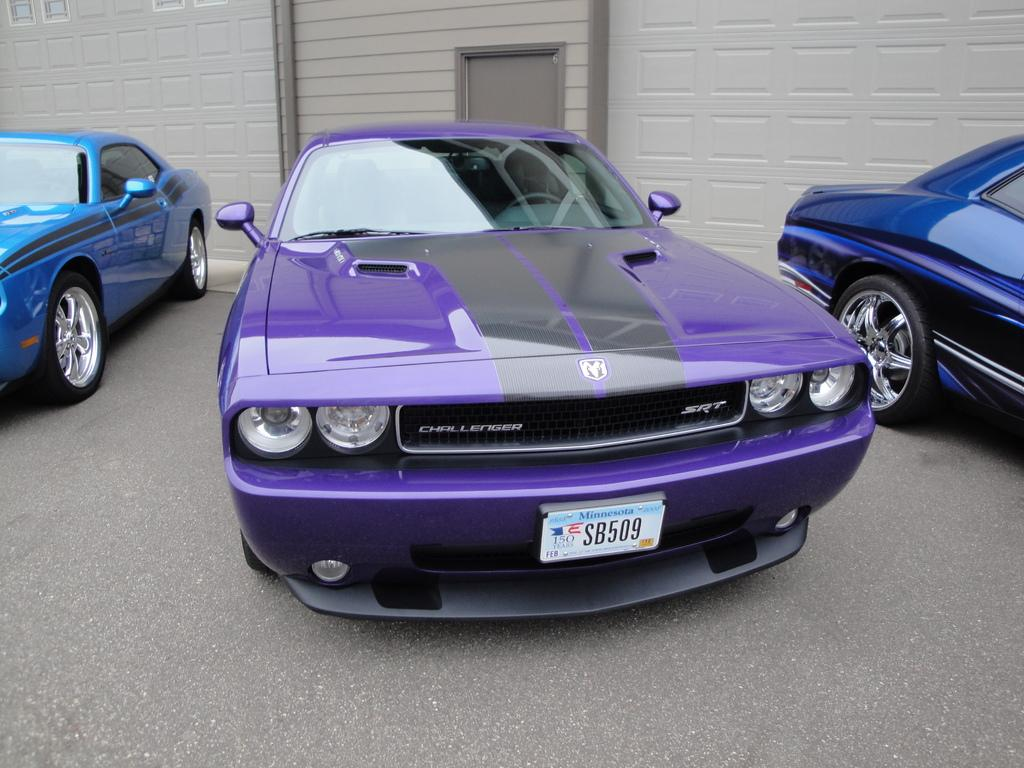What type of vehicles can be seen in the image? There are cars in the image. What architectural feature is visible in the image? There is a door of a building in the image. What can be seen in the image that might provide a view or access to the outdoors? There are windows in the image. What type of payment method is accepted at the volcano in the image? There is no volcano present in the image, so it is not possible to determine what payment method might be accepted. 